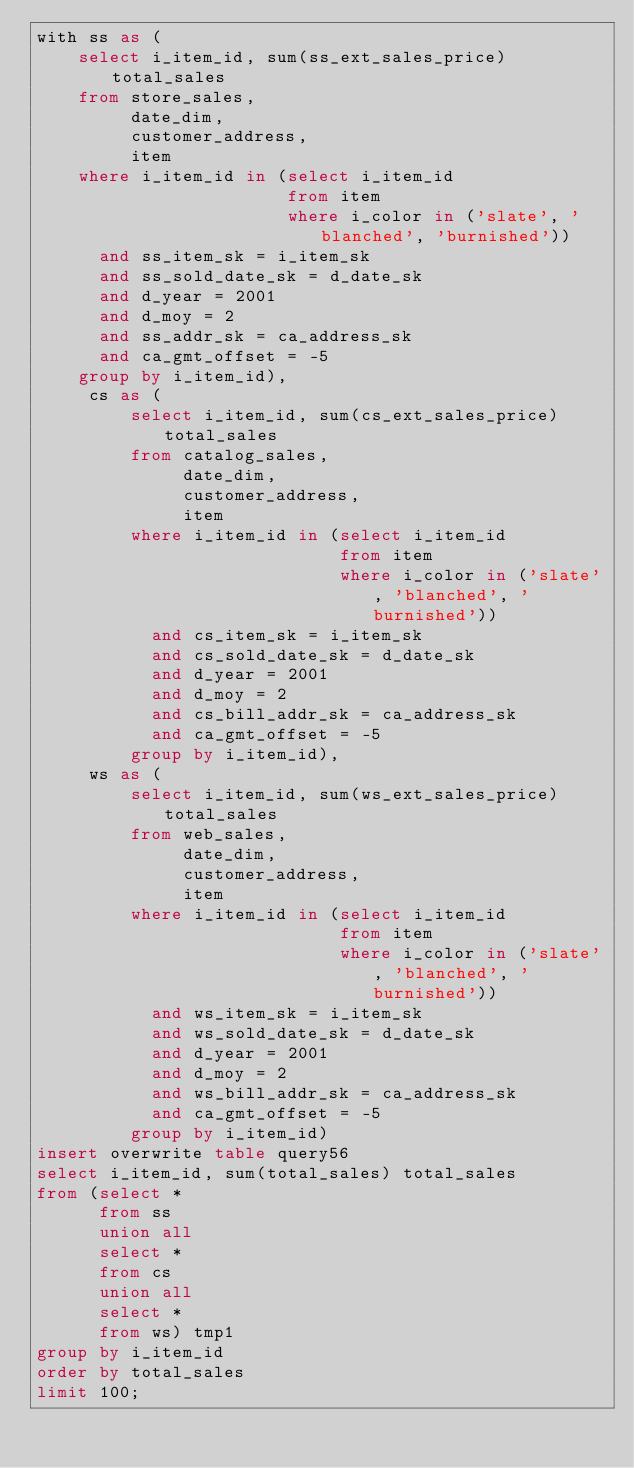<code> <loc_0><loc_0><loc_500><loc_500><_SQL_>with ss as (
    select i_item_id, sum(ss_ext_sales_price) total_sales
    from store_sales,
         date_dim,
         customer_address,
         item
    where i_item_id in (select i_item_id
                        from item
                        where i_color in ('slate', 'blanched', 'burnished'))
      and ss_item_sk = i_item_sk
      and ss_sold_date_sk = d_date_sk
      and d_year = 2001
      and d_moy = 2
      and ss_addr_sk = ca_address_sk
      and ca_gmt_offset = -5
    group by i_item_id),
     cs as (
         select i_item_id, sum(cs_ext_sales_price) total_sales
         from catalog_sales,
              date_dim,
              customer_address,
              item
         where i_item_id in (select i_item_id
                             from item
                             where i_color in ('slate', 'blanched', 'burnished'))
           and cs_item_sk = i_item_sk
           and cs_sold_date_sk = d_date_sk
           and d_year = 2001
           and d_moy = 2
           and cs_bill_addr_sk = ca_address_sk
           and ca_gmt_offset = -5
         group by i_item_id),
     ws as (
         select i_item_id, sum(ws_ext_sales_price) total_sales
         from web_sales,
              date_dim,
              customer_address,
              item
         where i_item_id in (select i_item_id
                             from item
                             where i_color in ('slate', 'blanched', 'burnished'))
           and ws_item_sk = i_item_sk
           and ws_sold_date_sk = d_date_sk
           and d_year = 2001
           and d_moy = 2
           and ws_bill_addr_sk = ca_address_sk
           and ca_gmt_offset = -5
         group by i_item_id)
insert overwrite table query56
select i_item_id, sum(total_sales) total_sales
from (select *
      from ss
      union all
      select *
      from cs
      union all
      select *
      from ws) tmp1
group by i_item_id
order by total_sales
limit 100;
</code> 